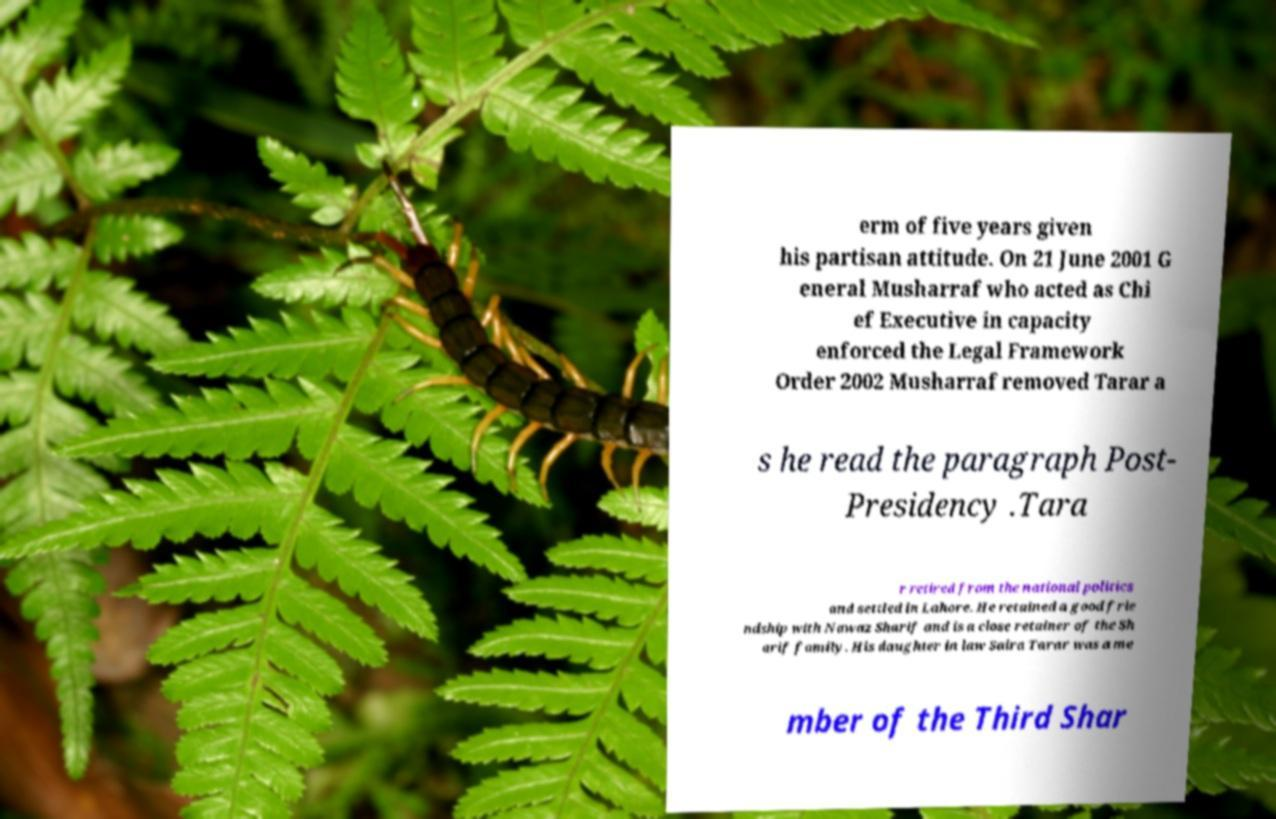Can you read and provide the text displayed in the image?This photo seems to have some interesting text. Can you extract and type it out for me? erm of five years given his partisan attitude. On 21 June 2001 G eneral Musharraf who acted as Chi ef Executive in capacity enforced the Legal Framework Order 2002 Musharraf removed Tarar a s he read the paragraph Post- Presidency .Tara r retired from the national politics and settled in Lahore. He retained a good frie ndship with Nawaz Sharif and is a close retainer of the Sh arif family. His daughter in law Saira Tarar was a me mber of the Third Shar 